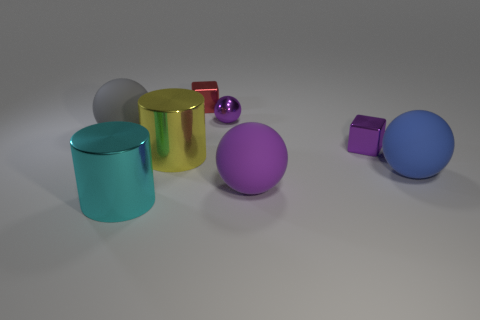Which object seems closest to the viewpoint and what can you infer about its texture? The object closest to the viewpoint is the large glossy blue sphere. Its smooth and reflective surface suggests that it has a polished texture, likely rendered to mimic a shiny, perhaps plastic or metallic, material. 